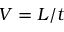<formula> <loc_0><loc_0><loc_500><loc_500>V = L / t</formula> 